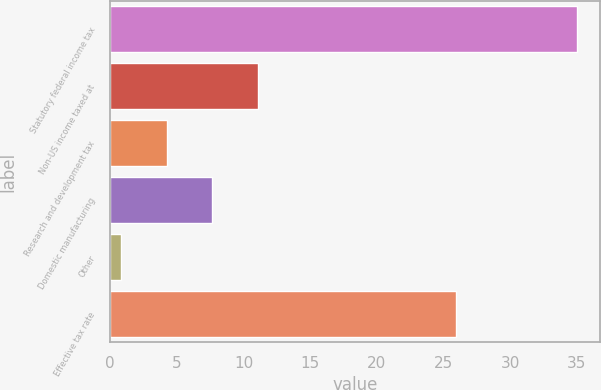<chart> <loc_0><loc_0><loc_500><loc_500><bar_chart><fcel>Statutory federal income tax<fcel>Non-US income taxed at<fcel>Research and development tax<fcel>Domestic manufacturing<fcel>Other<fcel>Effective tax rate<nl><fcel>35<fcel>11.06<fcel>4.22<fcel>7.64<fcel>0.8<fcel>25.9<nl></chart> 